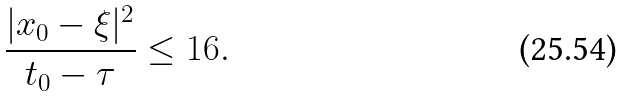Convert formula to latex. <formula><loc_0><loc_0><loc_500><loc_500>\frac { | x _ { 0 } - \xi | ^ { 2 } } { t _ { 0 } - \tau } \leq 1 6 .</formula> 